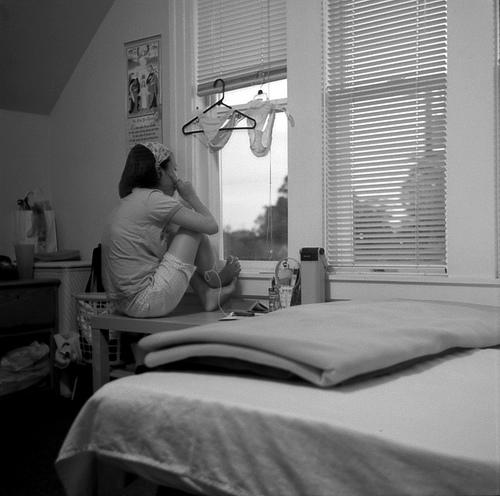Why are the underpants hanging there? Please explain your reasoning. to dry. They are wet 